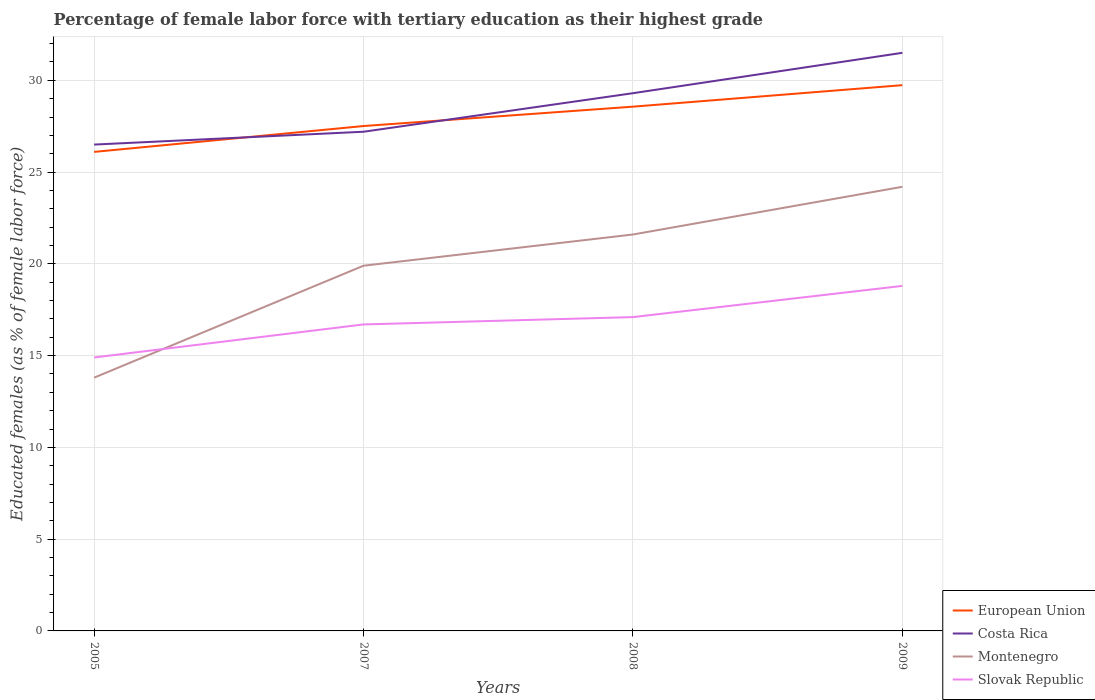Is the number of lines equal to the number of legend labels?
Provide a succinct answer. Yes. Across all years, what is the maximum percentage of female labor force with tertiary education in Slovak Republic?
Provide a short and direct response. 14.9. In which year was the percentage of female labor force with tertiary education in Costa Rica maximum?
Keep it short and to the point. 2005. What is the total percentage of female labor force with tertiary education in Montenegro in the graph?
Your answer should be compact. -1.7. What is the difference between the highest and the second highest percentage of female labor force with tertiary education in Slovak Republic?
Ensure brevity in your answer.  3.9. Is the percentage of female labor force with tertiary education in Montenegro strictly greater than the percentage of female labor force with tertiary education in Costa Rica over the years?
Make the answer very short. Yes. How many lines are there?
Keep it short and to the point. 4. Does the graph contain any zero values?
Ensure brevity in your answer.  No. What is the title of the graph?
Give a very brief answer. Percentage of female labor force with tertiary education as their highest grade. Does "Northern Mariana Islands" appear as one of the legend labels in the graph?
Offer a very short reply. No. What is the label or title of the Y-axis?
Offer a terse response. Educated females (as % of female labor force). What is the Educated females (as % of female labor force) of European Union in 2005?
Provide a short and direct response. 26.1. What is the Educated females (as % of female labor force) of Costa Rica in 2005?
Make the answer very short. 26.5. What is the Educated females (as % of female labor force) of Montenegro in 2005?
Provide a succinct answer. 13.8. What is the Educated females (as % of female labor force) of Slovak Republic in 2005?
Your answer should be very brief. 14.9. What is the Educated females (as % of female labor force) of European Union in 2007?
Ensure brevity in your answer.  27.51. What is the Educated females (as % of female labor force) of Costa Rica in 2007?
Your answer should be very brief. 27.2. What is the Educated females (as % of female labor force) in Montenegro in 2007?
Your response must be concise. 19.9. What is the Educated females (as % of female labor force) in Slovak Republic in 2007?
Your answer should be very brief. 16.7. What is the Educated females (as % of female labor force) of European Union in 2008?
Provide a succinct answer. 28.57. What is the Educated females (as % of female labor force) in Costa Rica in 2008?
Your answer should be compact. 29.3. What is the Educated females (as % of female labor force) of Montenegro in 2008?
Provide a succinct answer. 21.6. What is the Educated females (as % of female labor force) in Slovak Republic in 2008?
Offer a terse response. 17.1. What is the Educated females (as % of female labor force) of European Union in 2009?
Your answer should be very brief. 29.74. What is the Educated females (as % of female labor force) in Costa Rica in 2009?
Give a very brief answer. 31.5. What is the Educated females (as % of female labor force) in Montenegro in 2009?
Keep it short and to the point. 24.2. What is the Educated females (as % of female labor force) in Slovak Republic in 2009?
Make the answer very short. 18.8. Across all years, what is the maximum Educated females (as % of female labor force) of European Union?
Keep it short and to the point. 29.74. Across all years, what is the maximum Educated females (as % of female labor force) of Costa Rica?
Ensure brevity in your answer.  31.5. Across all years, what is the maximum Educated females (as % of female labor force) in Montenegro?
Make the answer very short. 24.2. Across all years, what is the maximum Educated females (as % of female labor force) of Slovak Republic?
Provide a short and direct response. 18.8. Across all years, what is the minimum Educated females (as % of female labor force) in European Union?
Offer a very short reply. 26.1. Across all years, what is the minimum Educated females (as % of female labor force) of Montenegro?
Offer a very short reply. 13.8. Across all years, what is the minimum Educated females (as % of female labor force) in Slovak Republic?
Keep it short and to the point. 14.9. What is the total Educated females (as % of female labor force) of European Union in the graph?
Your response must be concise. 111.91. What is the total Educated females (as % of female labor force) of Costa Rica in the graph?
Ensure brevity in your answer.  114.5. What is the total Educated females (as % of female labor force) in Montenegro in the graph?
Offer a very short reply. 79.5. What is the total Educated females (as % of female labor force) of Slovak Republic in the graph?
Provide a short and direct response. 67.5. What is the difference between the Educated females (as % of female labor force) of European Union in 2005 and that in 2007?
Offer a terse response. -1.41. What is the difference between the Educated females (as % of female labor force) in Costa Rica in 2005 and that in 2007?
Offer a terse response. -0.7. What is the difference between the Educated females (as % of female labor force) in Montenegro in 2005 and that in 2007?
Ensure brevity in your answer.  -6.1. What is the difference between the Educated females (as % of female labor force) of European Union in 2005 and that in 2008?
Provide a succinct answer. -2.46. What is the difference between the Educated females (as % of female labor force) in Montenegro in 2005 and that in 2008?
Provide a short and direct response. -7.8. What is the difference between the Educated females (as % of female labor force) in Slovak Republic in 2005 and that in 2008?
Your answer should be compact. -2.2. What is the difference between the Educated females (as % of female labor force) of European Union in 2005 and that in 2009?
Provide a short and direct response. -3.64. What is the difference between the Educated females (as % of female labor force) of Costa Rica in 2005 and that in 2009?
Give a very brief answer. -5. What is the difference between the Educated females (as % of female labor force) in Montenegro in 2005 and that in 2009?
Ensure brevity in your answer.  -10.4. What is the difference between the Educated females (as % of female labor force) of European Union in 2007 and that in 2008?
Make the answer very short. -1.06. What is the difference between the Educated females (as % of female labor force) of Slovak Republic in 2007 and that in 2008?
Provide a succinct answer. -0.4. What is the difference between the Educated females (as % of female labor force) in European Union in 2007 and that in 2009?
Your response must be concise. -2.23. What is the difference between the Educated females (as % of female labor force) in Montenegro in 2007 and that in 2009?
Offer a very short reply. -4.3. What is the difference between the Educated females (as % of female labor force) of Slovak Republic in 2007 and that in 2009?
Keep it short and to the point. -2.1. What is the difference between the Educated females (as % of female labor force) of European Union in 2008 and that in 2009?
Make the answer very short. -1.17. What is the difference between the Educated females (as % of female labor force) in Costa Rica in 2008 and that in 2009?
Make the answer very short. -2.2. What is the difference between the Educated females (as % of female labor force) in European Union in 2005 and the Educated females (as % of female labor force) in Costa Rica in 2007?
Provide a succinct answer. -1.1. What is the difference between the Educated females (as % of female labor force) in European Union in 2005 and the Educated females (as % of female labor force) in Montenegro in 2007?
Make the answer very short. 6.2. What is the difference between the Educated females (as % of female labor force) of European Union in 2005 and the Educated females (as % of female labor force) of Slovak Republic in 2007?
Make the answer very short. 9.4. What is the difference between the Educated females (as % of female labor force) in European Union in 2005 and the Educated females (as % of female labor force) in Costa Rica in 2008?
Provide a succinct answer. -3.2. What is the difference between the Educated females (as % of female labor force) of European Union in 2005 and the Educated females (as % of female labor force) of Montenegro in 2008?
Keep it short and to the point. 4.5. What is the difference between the Educated females (as % of female labor force) in European Union in 2005 and the Educated females (as % of female labor force) in Slovak Republic in 2008?
Your answer should be very brief. 9. What is the difference between the Educated females (as % of female labor force) of Costa Rica in 2005 and the Educated females (as % of female labor force) of Montenegro in 2008?
Keep it short and to the point. 4.9. What is the difference between the Educated females (as % of female labor force) of Costa Rica in 2005 and the Educated females (as % of female labor force) of Slovak Republic in 2008?
Make the answer very short. 9.4. What is the difference between the Educated females (as % of female labor force) in European Union in 2005 and the Educated females (as % of female labor force) in Costa Rica in 2009?
Offer a terse response. -5.4. What is the difference between the Educated females (as % of female labor force) in European Union in 2005 and the Educated females (as % of female labor force) in Montenegro in 2009?
Your answer should be compact. 1.9. What is the difference between the Educated females (as % of female labor force) in European Union in 2005 and the Educated females (as % of female labor force) in Slovak Republic in 2009?
Give a very brief answer. 7.3. What is the difference between the Educated females (as % of female labor force) in European Union in 2007 and the Educated females (as % of female labor force) in Costa Rica in 2008?
Offer a terse response. -1.79. What is the difference between the Educated females (as % of female labor force) in European Union in 2007 and the Educated females (as % of female labor force) in Montenegro in 2008?
Offer a terse response. 5.91. What is the difference between the Educated females (as % of female labor force) in European Union in 2007 and the Educated females (as % of female labor force) in Slovak Republic in 2008?
Your response must be concise. 10.41. What is the difference between the Educated females (as % of female labor force) in Costa Rica in 2007 and the Educated females (as % of female labor force) in Montenegro in 2008?
Your response must be concise. 5.6. What is the difference between the Educated females (as % of female labor force) of European Union in 2007 and the Educated females (as % of female labor force) of Costa Rica in 2009?
Ensure brevity in your answer.  -3.99. What is the difference between the Educated females (as % of female labor force) in European Union in 2007 and the Educated females (as % of female labor force) in Montenegro in 2009?
Make the answer very short. 3.31. What is the difference between the Educated females (as % of female labor force) of European Union in 2007 and the Educated females (as % of female labor force) of Slovak Republic in 2009?
Provide a short and direct response. 8.71. What is the difference between the Educated females (as % of female labor force) of Costa Rica in 2007 and the Educated females (as % of female labor force) of Montenegro in 2009?
Ensure brevity in your answer.  3. What is the difference between the Educated females (as % of female labor force) of Costa Rica in 2007 and the Educated females (as % of female labor force) of Slovak Republic in 2009?
Provide a short and direct response. 8.4. What is the difference between the Educated females (as % of female labor force) of Montenegro in 2007 and the Educated females (as % of female labor force) of Slovak Republic in 2009?
Ensure brevity in your answer.  1.1. What is the difference between the Educated females (as % of female labor force) of European Union in 2008 and the Educated females (as % of female labor force) of Costa Rica in 2009?
Ensure brevity in your answer.  -2.93. What is the difference between the Educated females (as % of female labor force) in European Union in 2008 and the Educated females (as % of female labor force) in Montenegro in 2009?
Your answer should be compact. 4.37. What is the difference between the Educated females (as % of female labor force) in European Union in 2008 and the Educated females (as % of female labor force) in Slovak Republic in 2009?
Offer a very short reply. 9.77. What is the difference between the Educated females (as % of female labor force) of Costa Rica in 2008 and the Educated females (as % of female labor force) of Montenegro in 2009?
Offer a terse response. 5.1. What is the average Educated females (as % of female labor force) of European Union per year?
Offer a terse response. 27.98. What is the average Educated females (as % of female labor force) of Costa Rica per year?
Your answer should be very brief. 28.62. What is the average Educated females (as % of female labor force) in Montenegro per year?
Offer a very short reply. 19.88. What is the average Educated females (as % of female labor force) of Slovak Republic per year?
Ensure brevity in your answer.  16.88. In the year 2005, what is the difference between the Educated females (as % of female labor force) in European Union and Educated females (as % of female labor force) in Costa Rica?
Keep it short and to the point. -0.4. In the year 2005, what is the difference between the Educated females (as % of female labor force) in European Union and Educated females (as % of female labor force) in Montenegro?
Ensure brevity in your answer.  12.3. In the year 2005, what is the difference between the Educated females (as % of female labor force) of European Union and Educated females (as % of female labor force) of Slovak Republic?
Your answer should be compact. 11.2. In the year 2007, what is the difference between the Educated females (as % of female labor force) in European Union and Educated females (as % of female labor force) in Costa Rica?
Provide a short and direct response. 0.31. In the year 2007, what is the difference between the Educated females (as % of female labor force) in European Union and Educated females (as % of female labor force) in Montenegro?
Ensure brevity in your answer.  7.61. In the year 2007, what is the difference between the Educated females (as % of female labor force) in European Union and Educated females (as % of female labor force) in Slovak Republic?
Your response must be concise. 10.81. In the year 2007, what is the difference between the Educated females (as % of female labor force) of Costa Rica and Educated females (as % of female labor force) of Montenegro?
Give a very brief answer. 7.3. In the year 2007, what is the difference between the Educated females (as % of female labor force) of Costa Rica and Educated females (as % of female labor force) of Slovak Republic?
Keep it short and to the point. 10.5. In the year 2008, what is the difference between the Educated females (as % of female labor force) of European Union and Educated females (as % of female labor force) of Costa Rica?
Your response must be concise. -0.73. In the year 2008, what is the difference between the Educated females (as % of female labor force) in European Union and Educated females (as % of female labor force) in Montenegro?
Offer a terse response. 6.97. In the year 2008, what is the difference between the Educated females (as % of female labor force) of European Union and Educated females (as % of female labor force) of Slovak Republic?
Offer a very short reply. 11.47. In the year 2008, what is the difference between the Educated females (as % of female labor force) of Costa Rica and Educated females (as % of female labor force) of Slovak Republic?
Provide a short and direct response. 12.2. In the year 2009, what is the difference between the Educated females (as % of female labor force) of European Union and Educated females (as % of female labor force) of Costa Rica?
Provide a short and direct response. -1.76. In the year 2009, what is the difference between the Educated females (as % of female labor force) in European Union and Educated females (as % of female labor force) in Montenegro?
Offer a terse response. 5.54. In the year 2009, what is the difference between the Educated females (as % of female labor force) of European Union and Educated females (as % of female labor force) of Slovak Republic?
Make the answer very short. 10.94. In the year 2009, what is the difference between the Educated females (as % of female labor force) in Costa Rica and Educated females (as % of female labor force) in Slovak Republic?
Give a very brief answer. 12.7. In the year 2009, what is the difference between the Educated females (as % of female labor force) of Montenegro and Educated females (as % of female labor force) of Slovak Republic?
Offer a very short reply. 5.4. What is the ratio of the Educated females (as % of female labor force) in European Union in 2005 to that in 2007?
Offer a terse response. 0.95. What is the ratio of the Educated females (as % of female labor force) of Costa Rica in 2005 to that in 2007?
Your response must be concise. 0.97. What is the ratio of the Educated females (as % of female labor force) of Montenegro in 2005 to that in 2007?
Offer a very short reply. 0.69. What is the ratio of the Educated females (as % of female labor force) of Slovak Republic in 2005 to that in 2007?
Give a very brief answer. 0.89. What is the ratio of the Educated females (as % of female labor force) of European Union in 2005 to that in 2008?
Provide a succinct answer. 0.91. What is the ratio of the Educated females (as % of female labor force) in Costa Rica in 2005 to that in 2008?
Your answer should be compact. 0.9. What is the ratio of the Educated females (as % of female labor force) of Montenegro in 2005 to that in 2008?
Offer a very short reply. 0.64. What is the ratio of the Educated females (as % of female labor force) in Slovak Republic in 2005 to that in 2008?
Offer a very short reply. 0.87. What is the ratio of the Educated females (as % of female labor force) in European Union in 2005 to that in 2009?
Your response must be concise. 0.88. What is the ratio of the Educated females (as % of female labor force) of Costa Rica in 2005 to that in 2009?
Your response must be concise. 0.84. What is the ratio of the Educated females (as % of female labor force) of Montenegro in 2005 to that in 2009?
Offer a terse response. 0.57. What is the ratio of the Educated females (as % of female labor force) in Slovak Republic in 2005 to that in 2009?
Your answer should be compact. 0.79. What is the ratio of the Educated females (as % of female labor force) of European Union in 2007 to that in 2008?
Offer a terse response. 0.96. What is the ratio of the Educated females (as % of female labor force) of Costa Rica in 2007 to that in 2008?
Your answer should be very brief. 0.93. What is the ratio of the Educated females (as % of female labor force) of Montenegro in 2007 to that in 2008?
Your answer should be very brief. 0.92. What is the ratio of the Educated females (as % of female labor force) in Slovak Republic in 2007 to that in 2008?
Keep it short and to the point. 0.98. What is the ratio of the Educated females (as % of female labor force) of European Union in 2007 to that in 2009?
Offer a terse response. 0.93. What is the ratio of the Educated females (as % of female labor force) of Costa Rica in 2007 to that in 2009?
Your answer should be compact. 0.86. What is the ratio of the Educated females (as % of female labor force) in Montenegro in 2007 to that in 2009?
Ensure brevity in your answer.  0.82. What is the ratio of the Educated females (as % of female labor force) in Slovak Republic in 2007 to that in 2009?
Keep it short and to the point. 0.89. What is the ratio of the Educated females (as % of female labor force) of European Union in 2008 to that in 2009?
Give a very brief answer. 0.96. What is the ratio of the Educated females (as % of female labor force) of Costa Rica in 2008 to that in 2009?
Make the answer very short. 0.93. What is the ratio of the Educated females (as % of female labor force) in Montenegro in 2008 to that in 2009?
Your response must be concise. 0.89. What is the ratio of the Educated females (as % of female labor force) in Slovak Republic in 2008 to that in 2009?
Ensure brevity in your answer.  0.91. What is the difference between the highest and the second highest Educated females (as % of female labor force) in European Union?
Keep it short and to the point. 1.17. What is the difference between the highest and the second highest Educated females (as % of female labor force) of Montenegro?
Provide a succinct answer. 2.6. What is the difference between the highest and the lowest Educated females (as % of female labor force) in European Union?
Your answer should be compact. 3.64. What is the difference between the highest and the lowest Educated females (as % of female labor force) in Costa Rica?
Give a very brief answer. 5. What is the difference between the highest and the lowest Educated females (as % of female labor force) in Montenegro?
Give a very brief answer. 10.4. What is the difference between the highest and the lowest Educated females (as % of female labor force) in Slovak Republic?
Ensure brevity in your answer.  3.9. 